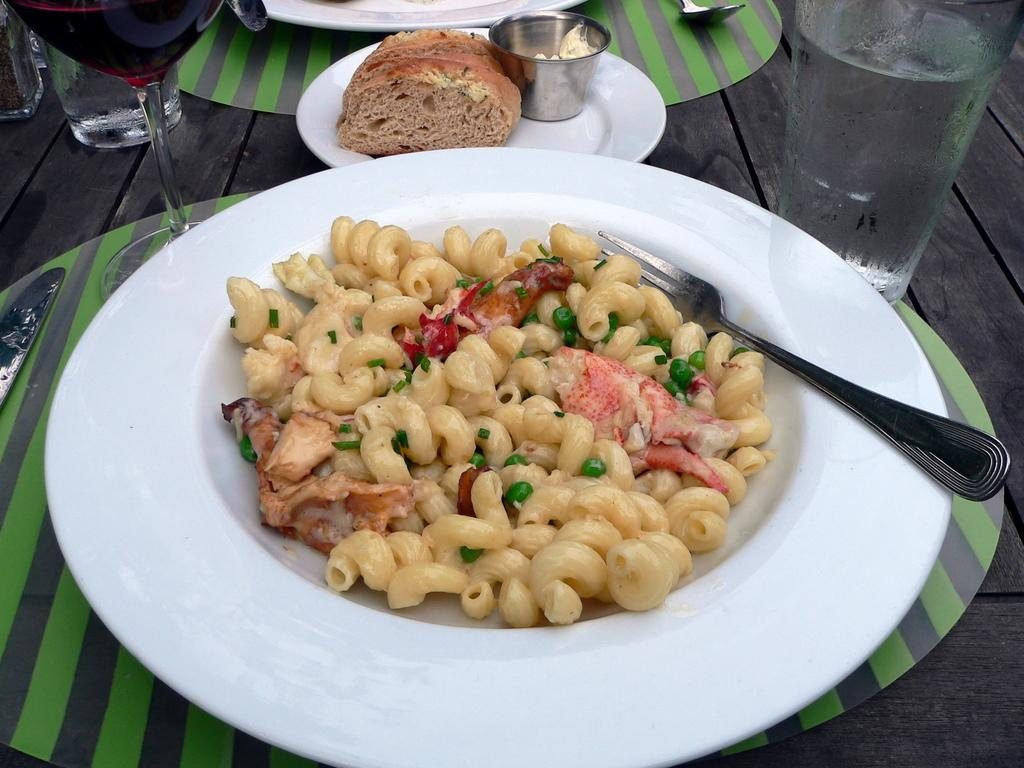What can be found on the plates in the image? There are food items in the plates in the image. What type of beverage is in the glass in the image? There is a glass of water in the image. What type of coast can be seen in the image? There is no coast visible in the image; it features plates with food items and a glass of water. What kind of property is depicted in the image? The image does not depict any property; it only shows plates with food items and a glass of water. 